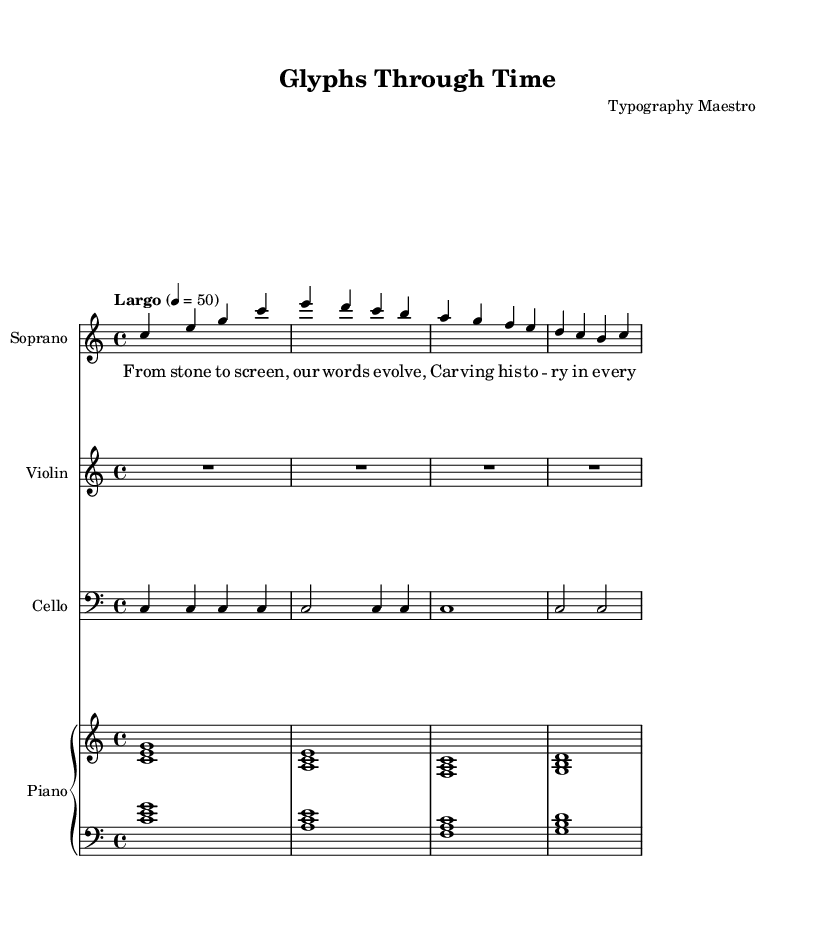What is the key signature of this music? The key signature is C major, which is indicated by the absence of sharps or flats before the notes.
Answer: C major What is the time signature of this music? The time signature is located at the start of the section; it shows a 4 over 4, indicating four beats per measure.
Answer: 4/4 What is the tempo marking of this composition? The tempo marking is found at the beginning of the score, designated as "Largo," with a metronome marking of 50 beats per minute.
Answer: Largo How many staves are present for the instruments? There are four distinct staves visible for the included instruments: soprano, violin, cello, and piano.
Answer: Four What dynamics are indicated in the soprano part? The rendering of the music does not visually represent any dynamic markings within the soprano part. Therefore, the answer is that they are not indicated.
Answer: None What is the text of the lyrics set to the soprano voice? The lyrics can be found underneath the soprano notes, stating, "From stone to screen, our words evolve..." detailing the evolution of written communication.
Answer: From stone to screen, our words evolve How does the cello part relate to the overall texture of the opera? The cello provides a sustained bass foundation that underpins the harmonic structure of the opera, emphasizing the minimalist approach.
Answer: Sustained bass foundation 